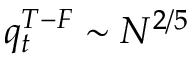<formula> <loc_0><loc_0><loc_500><loc_500>q _ { t } ^ { T - F } \sim N ^ { 2 / 5 }</formula> 